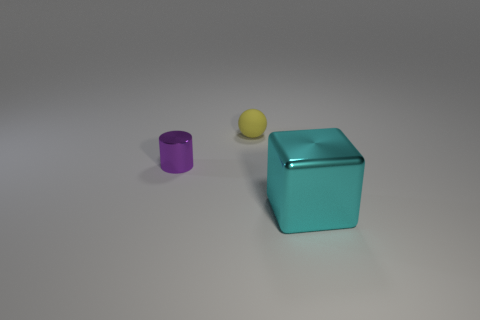Are there the same number of tiny yellow balls in front of the small purple thing and large matte blocks?
Your answer should be very brief. Yes. What number of spheres are metallic things or cyan objects?
Your answer should be compact. 0. There is a small cylinder that is made of the same material as the large block; what color is it?
Provide a succinct answer. Purple. Is the cyan thing made of the same material as the tiny thing that is in front of the ball?
Give a very brief answer. Yes. What number of objects are matte balls or large cyan metal objects?
Your response must be concise. 2. There is a tiny rubber thing; what number of big cyan cubes are in front of it?
Ensure brevity in your answer.  1. There is a object that is behind the metallic thing that is left of the large block; what is it made of?
Your answer should be compact. Rubber. There is a thing that is the same size as the purple metal cylinder; what is it made of?
Provide a succinct answer. Rubber. Are there any green matte things of the same size as the yellow thing?
Provide a succinct answer. No. The object left of the yellow thing is what color?
Your answer should be very brief. Purple. 